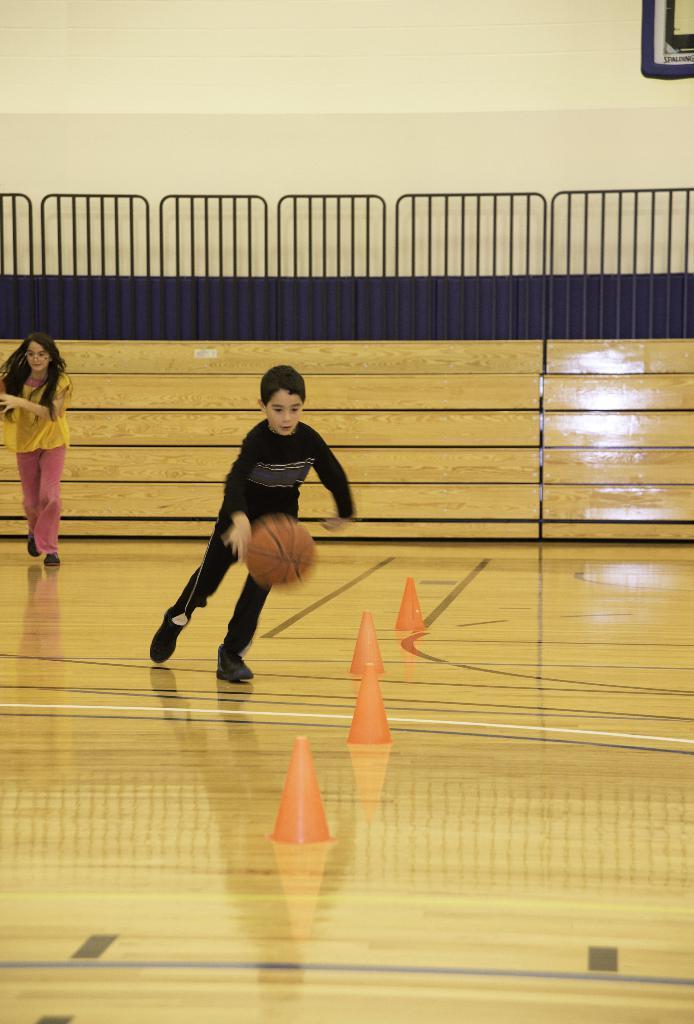Please provide a concise description of this image. In this image we can see a boy is playing with the ball, he is wearing black color dress. To the left side of the image one girl is there, she is wearing yellow top with pink pant. The floor is furnished with wood. Background black color fence is there and the wall is in white color. 